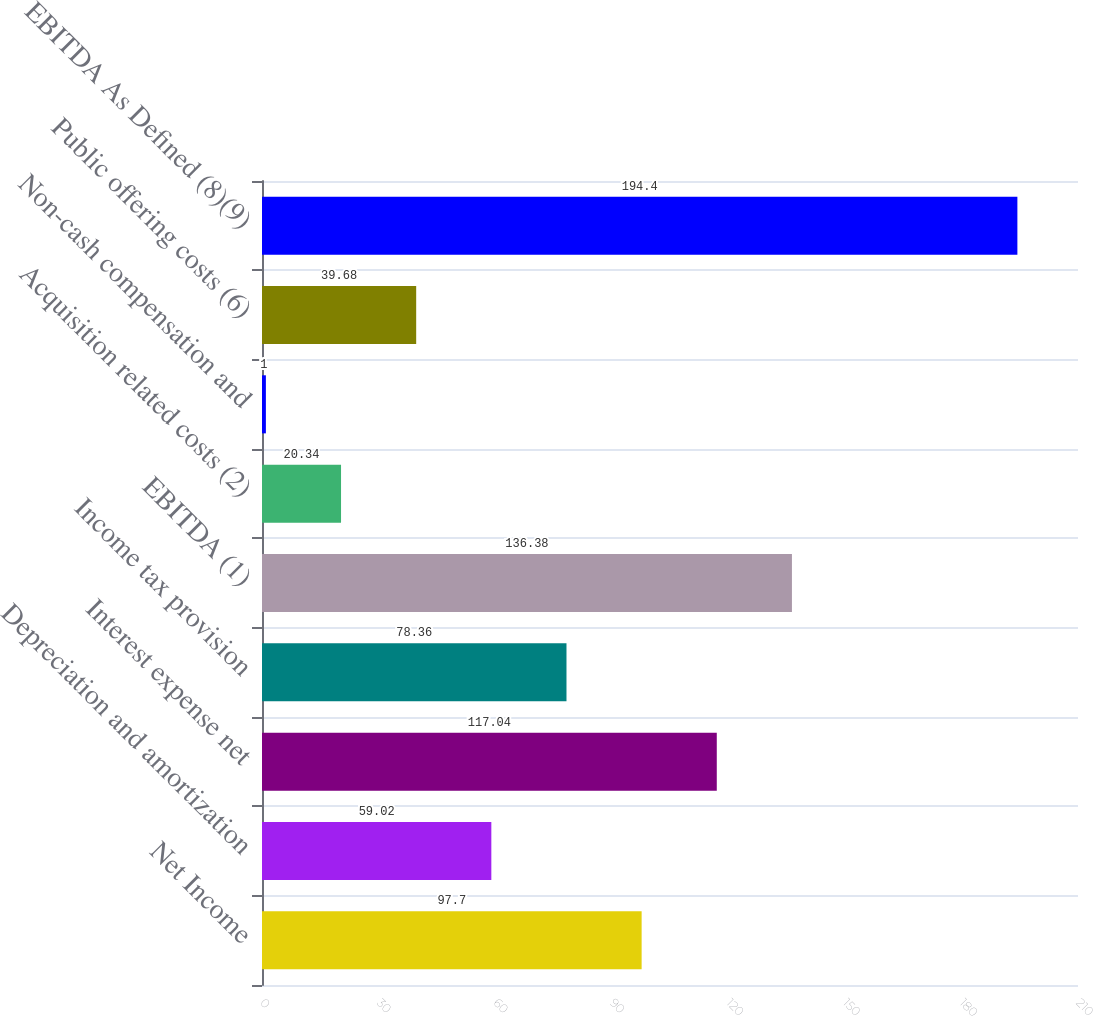Convert chart to OTSL. <chart><loc_0><loc_0><loc_500><loc_500><bar_chart><fcel>Net Income<fcel>Depreciation and amortization<fcel>Interest expense net<fcel>Income tax provision<fcel>EBITDA (1)<fcel>Acquisition related costs (2)<fcel>Non-cash compensation and<fcel>Public offering costs (6)<fcel>EBITDA As Defined (8)(9)<nl><fcel>97.7<fcel>59.02<fcel>117.04<fcel>78.36<fcel>136.38<fcel>20.34<fcel>1<fcel>39.68<fcel>194.4<nl></chart> 